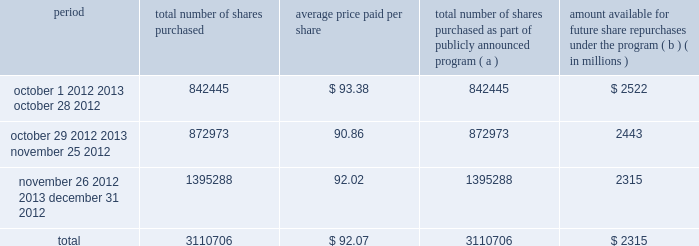Issuer purchases of equity securities the table provides information about our repurchases of common stock during the three-month period ended december 31 , 2012 .
Period total number of shares purchased average price paid per total number of shares purchased as part of publicly announced program ( a ) amount available for future share repurchases the program ( b ) ( in millions ) .
( a ) we repurchased a total of 3.1 million shares of our common stock for $ 286 million during the quarter ended december 31 , 2012 under a share repurchase program that we announced in october 2010 .
( b ) our board of directors has approved a share repurchase program for the repurchase of our common stock from time-to-time , authorizing an amount available for share repurchases of $ 6.5 billion .
Under the program , management has discretion to determine the dollar amount of shares to be repurchased and the timing of any repurchases in compliance with applicable law and regulation .
The program does not have an expiration date .
As of december 31 , 2012 , we had repurchased a total of 54.3 million shares under the program for $ 4.2 billion. .
What is the total value of repurchased shares during october 2012 , in millions? 
Computations: ((842445 * 93.38) / 1000000)
Answer: 78.66751. 